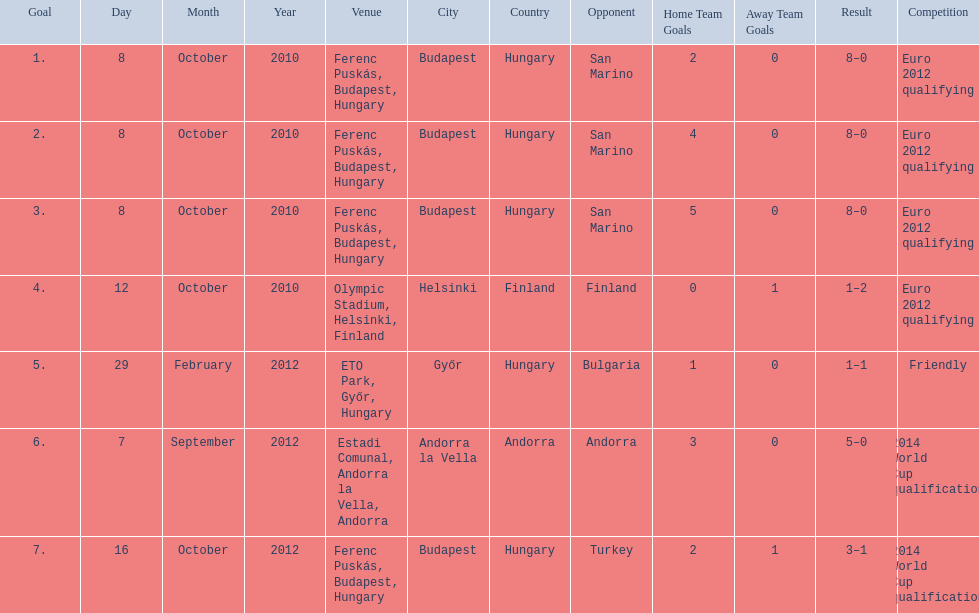What is the total number of international goals ádám szalai has made? 7. 